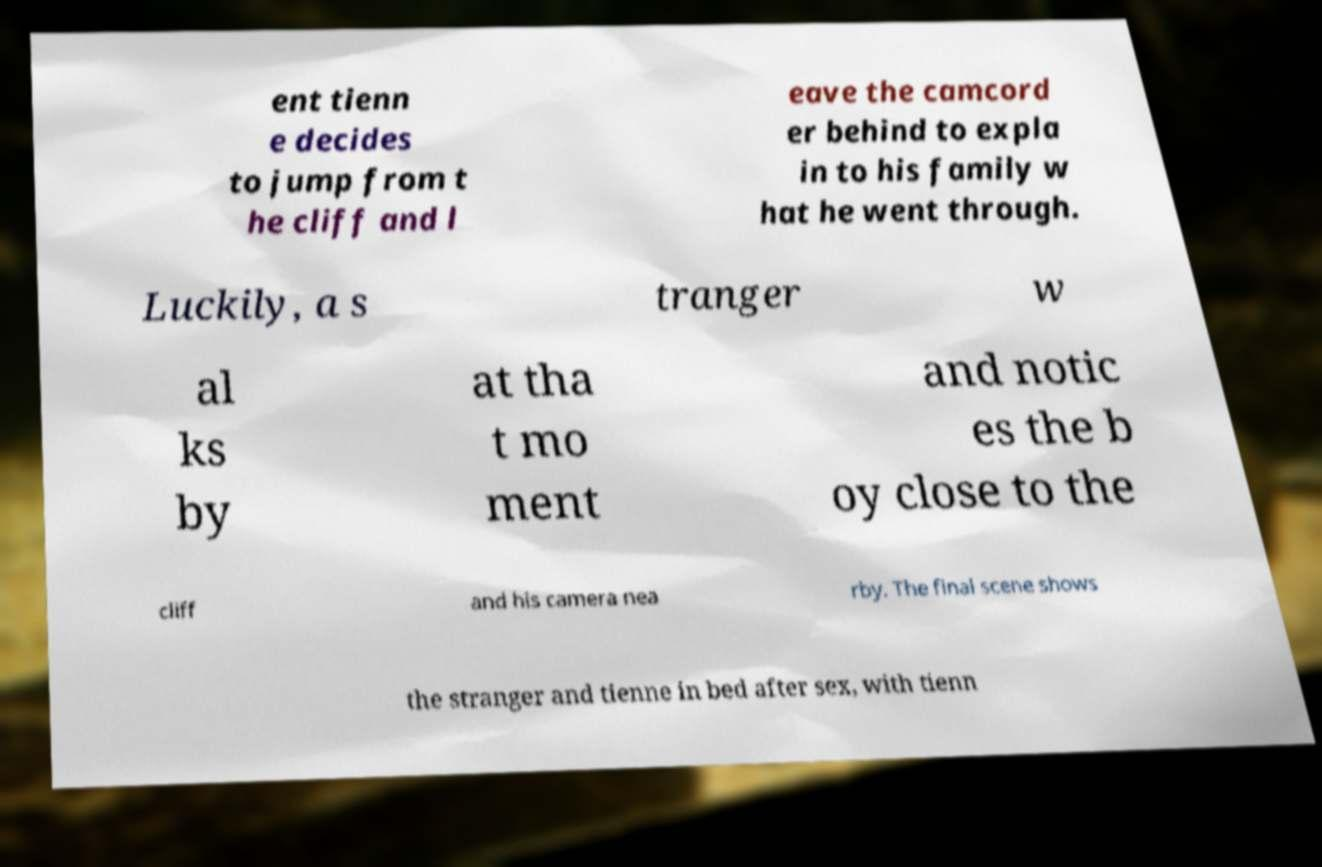Can you accurately transcribe the text from the provided image for me? ent tienn e decides to jump from t he cliff and l eave the camcord er behind to expla in to his family w hat he went through. Luckily, a s tranger w al ks by at tha t mo ment and notic es the b oy close to the cliff and his camera nea rby. The final scene shows the stranger and tienne in bed after sex, with tienn 